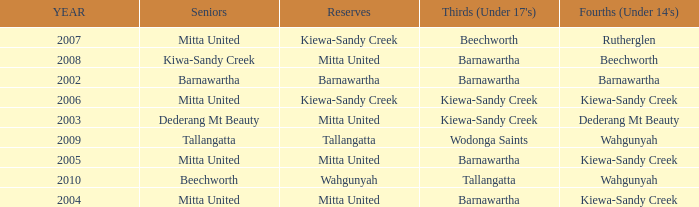Which Seniors have YEAR before 2006, and Fourths (Under 14's) of kiewa-sandy creek? Mitta United, Mitta United. 